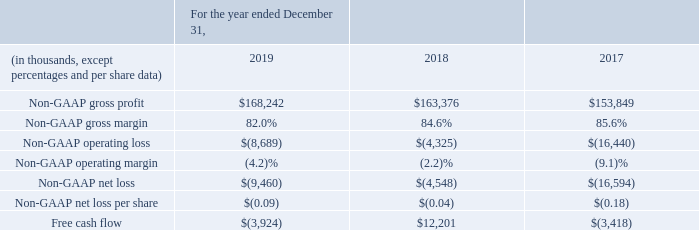Free cash flow
Our non-GAAP financial measures also include free cash flow, which we define as cash provided by (used in) operating activities less the amount of property and equipment purchased. Management believes that information regarding free cash flow provides investors with an important perspective on the cash available to invest in our business and fund ongoing operations.

However, our calculation of free cash flow may not be comparable to similar measures used by other companies.
We believe these non-GAAP financial measures are helpful in understanding our past financial performance and our future results. Our non-GAAP financial measures are not meant to be considered in isolation or as a substitute for comparable GAAP measures and should be read only in conjunction with our consolidated financial statements prepared in accordance with GAAP.

Our management regularly uses our supplemental non-GAAP financial measures internally to understand, manage and evaluate our business, and make operating decisions. These non-GAAP measures are among the primary factors management uses in planning for and forecasting future periods. Compensation of our executives is based in part on the performance of our business based on certain of these non-GAAP measures.
We monitor the following non-GAAP financial measures:
What is free cash flow? Cash provided by (used in) operating activities less the amount of property and equipment purchased. How does management use non-GAAP measures? Planning for and forecasting future periods, understand, manage and evaluate our business, and make operating decisions. What does information about free cash flow provide investors with? An important perspective on the cash available to invest in our business and fund ongoing operations. What was the average non-GAAP gross profit for the 3 year period from 2017 to 2019?
Answer scale should be: thousand. (168,242+163,376+153,849)/3
Answer: 161822.33. What was the % change in the free cash flow from 2017 to 2018?
Answer scale should be: percent. (12,201-(-3,418))/-3,418
Answer: -456.96. What is the change in non-GAAP gross profit between 2017 and 2019, as a % of the total gross profit for 2018?
Answer scale should be: percent. (168,242-153,849)/163,376
Answer: 8.81. 